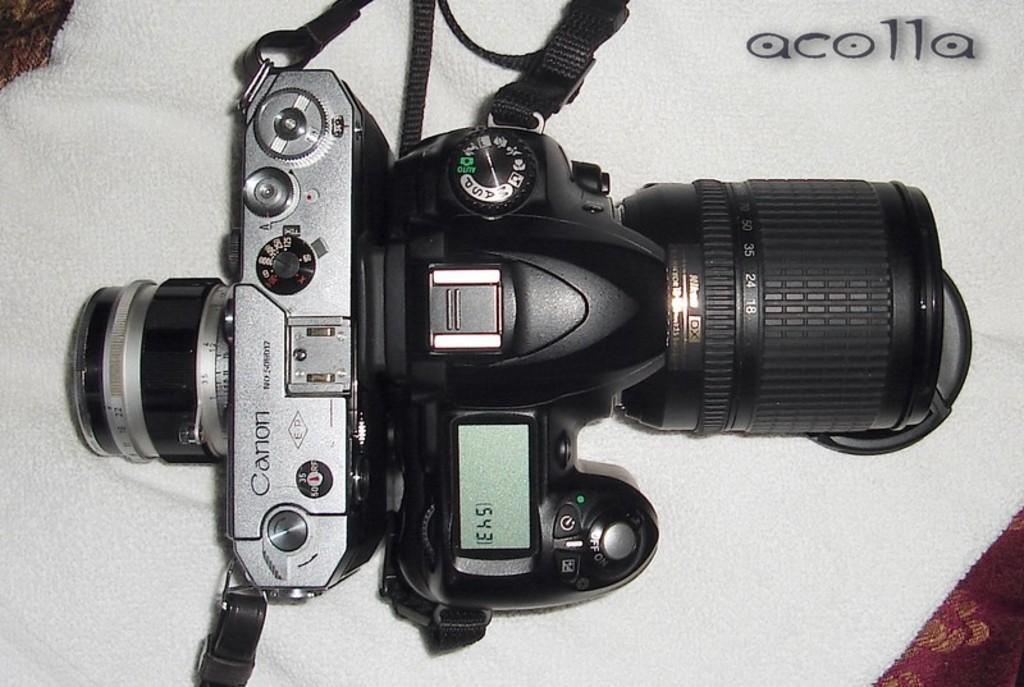Could you give a brief overview of what you see in this image? In this picture we can see a camera on a platform, in the top right we can see some text on it. 